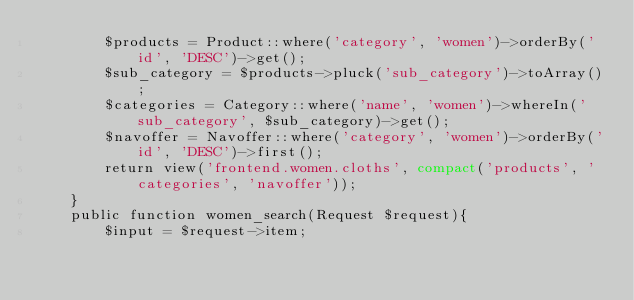Convert code to text. <code><loc_0><loc_0><loc_500><loc_500><_PHP_>        $products = Product::where('category', 'women')->orderBy('id', 'DESC')->get();
        $sub_category = $products->pluck('sub_category')->toArray();
        $categories = Category::where('name', 'women')->whereIn('sub_category', $sub_category)->get();
        $navoffer = Navoffer::where('category', 'women')->orderBy('id', 'DESC')->first();
        return view('frontend.women.cloths', compact('products', 'categories', 'navoffer'));
    }
    public function women_search(Request $request){
        $input = $request->item;</code> 